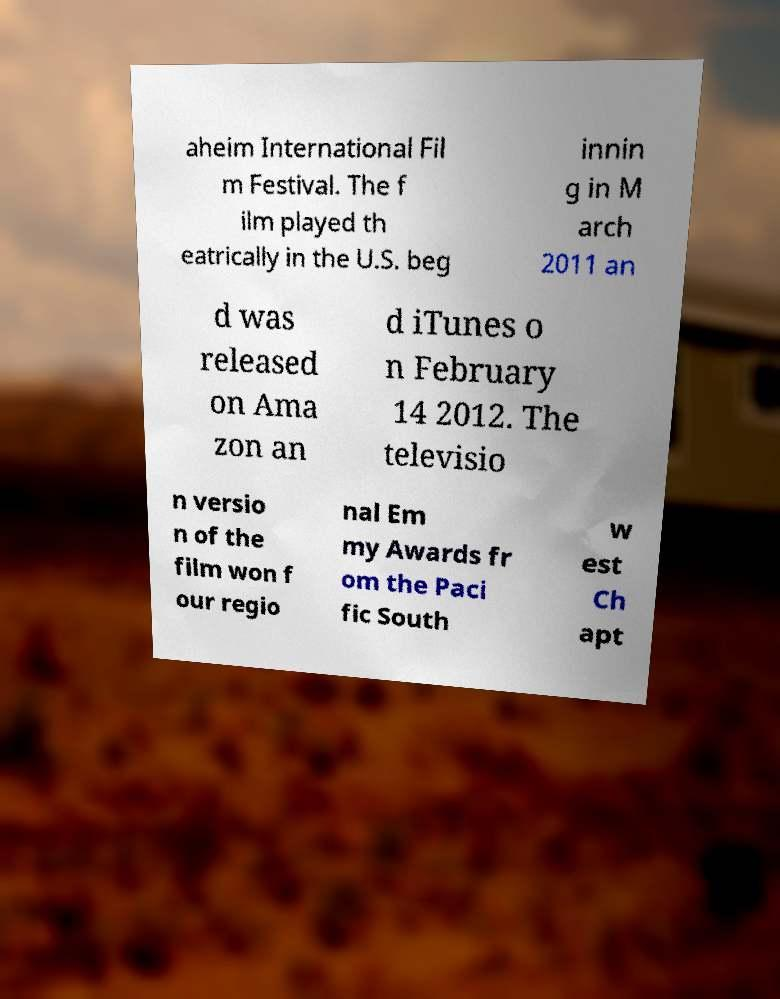There's text embedded in this image that I need extracted. Can you transcribe it verbatim? aheim International Fil m Festival. The f ilm played th eatrically in the U.S. beg innin g in M arch 2011 an d was released on Ama zon an d iTunes o n February 14 2012. The televisio n versio n of the film won f our regio nal Em my Awards fr om the Paci fic South w est Ch apt 